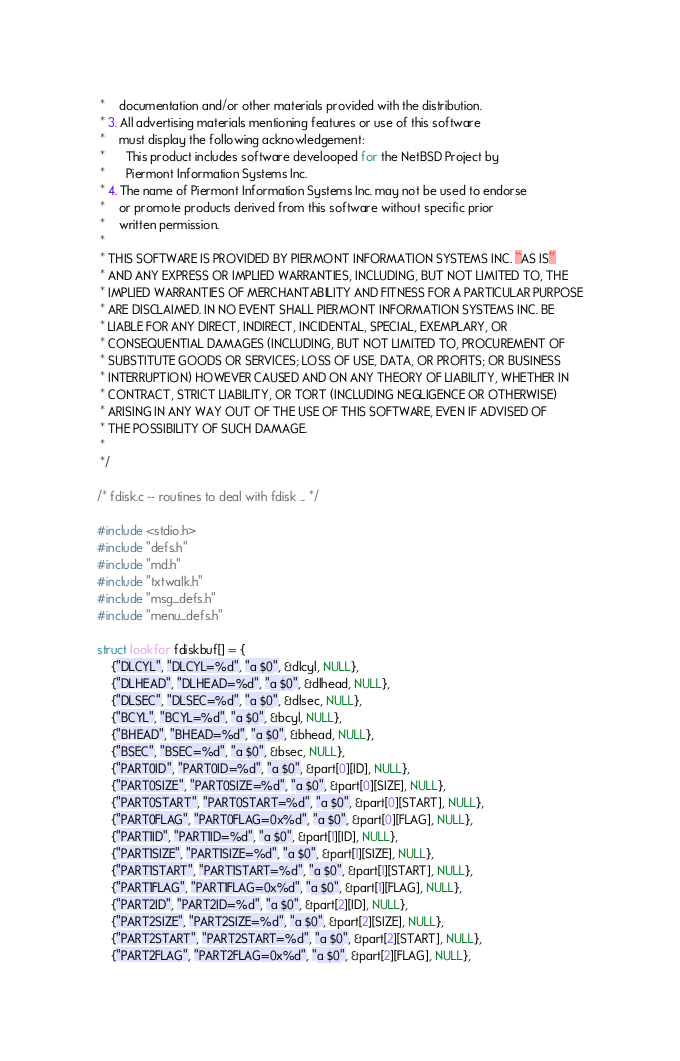<code> <loc_0><loc_0><loc_500><loc_500><_C_> *    documentation and/or other materials provided with the distribution.
 * 3. All advertising materials mentioning features or use of this software
 *    must display the following acknowledgement:
 *      This product includes software develooped for the NetBSD Project by
 *      Piermont Information Systems Inc.
 * 4. The name of Piermont Information Systems Inc. may not be used to endorse
 *    or promote products derived from this software without specific prior
 *    written permission.
 *
 * THIS SOFTWARE IS PROVIDED BY PIERMONT INFORMATION SYSTEMS INC. ``AS IS''
 * AND ANY EXPRESS OR IMPLIED WARRANTIES, INCLUDING, BUT NOT LIMITED TO, THE
 * IMPLIED WARRANTIES OF MERCHANTABILITY AND FITNESS FOR A PARTICULAR PURPOSE
 * ARE DISCLAIMED. IN NO EVENT SHALL PIERMONT INFORMATION SYSTEMS INC. BE 
 * LIABLE FOR ANY DIRECT, INDIRECT, INCIDENTAL, SPECIAL, EXEMPLARY, OR 
 * CONSEQUENTIAL DAMAGES (INCLUDING, BUT NOT LIMITED TO, PROCUREMENT OF 
 * SUBSTITUTE GOODS OR SERVICES; LOSS OF USE, DATA, OR PROFITS; OR BUSINESS
 * INTERRUPTION) HOWEVER CAUSED AND ON ANY THEORY OF LIABILITY, WHETHER IN
 * CONTRACT, STRICT LIABILITY, OR TORT (INCLUDING NEGLIGENCE OR OTHERWISE)
 * ARISING IN ANY WAY OUT OF THE USE OF THIS SOFTWARE, EVEN IF ADVISED OF 
 * THE POSSIBILITY OF SUCH DAMAGE.
 *
 */

/* fdisk.c -- routines to deal with fdisk ... */

#include <stdio.h>
#include "defs.h"
#include "md.h"
#include "txtwalk.h"
#include "msg_defs.h"
#include "menu_defs.h"

struct lookfor fdiskbuf[] = {
	{"DLCYL", "DLCYL=%d", "a $0", &dlcyl, NULL},
	{"DLHEAD", "DLHEAD=%d", "a $0", &dlhead, NULL},
	{"DLSEC", "DLSEC=%d", "a $0", &dlsec, NULL},
	{"BCYL", "BCYL=%d", "a $0", &bcyl, NULL},
	{"BHEAD", "BHEAD=%d", "a $0", &bhead, NULL},
	{"BSEC", "BSEC=%d", "a $0", &bsec, NULL},
	{"PART0ID", "PART0ID=%d", "a $0", &part[0][ID], NULL},
	{"PART0SIZE", "PART0SIZE=%d", "a $0", &part[0][SIZE], NULL},
	{"PART0START", "PART0START=%d", "a $0", &part[0][START], NULL},
	{"PART0FLAG", "PART0FLAG=0x%d", "a $0", &part[0][FLAG], NULL},
	{"PART1ID", "PART1ID=%d", "a $0", &part[1][ID], NULL},
	{"PART1SIZE", "PART1SIZE=%d", "a $0", &part[1][SIZE], NULL},
	{"PART1START", "PART1START=%d", "a $0", &part[1][START], NULL},
	{"PART1FLAG", "PART1FLAG=0x%d", "a $0", &part[1][FLAG], NULL},
	{"PART2ID", "PART2ID=%d", "a $0", &part[2][ID], NULL},
	{"PART2SIZE", "PART2SIZE=%d", "a $0", &part[2][SIZE], NULL},
	{"PART2START", "PART2START=%d", "a $0", &part[2][START], NULL},
	{"PART2FLAG", "PART2FLAG=0x%d", "a $0", &part[2][FLAG], NULL},</code> 